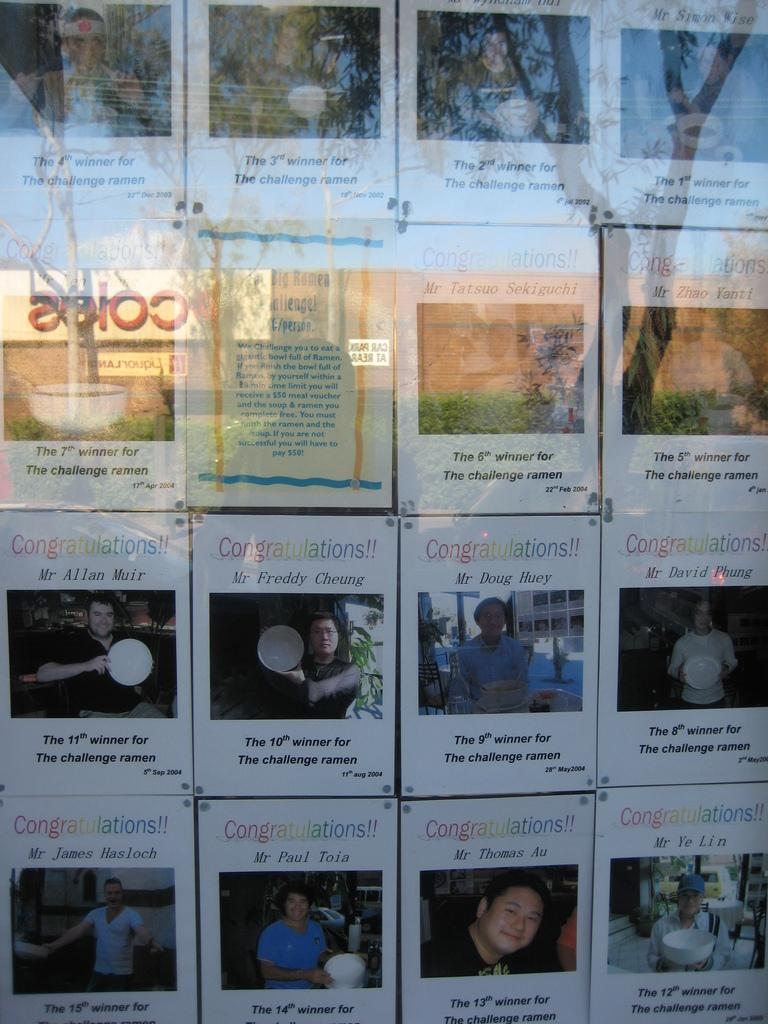What type of images can be seen in the picture? There are photos of people in the image. What natural elements are visible in the image? There are trees visible in the image. Can you describe any other objects present in the image? Unfortunately, the specific nature of other objects in the image is not clear from the transcript. How many tigers are sitting on the branches of the trees in the image? There are no tigers present in the image; it features photos of people and trees. What type of frogs can be seen hopping around the people in the image? There are no frogs present in the image; it features photos of people and trees. 